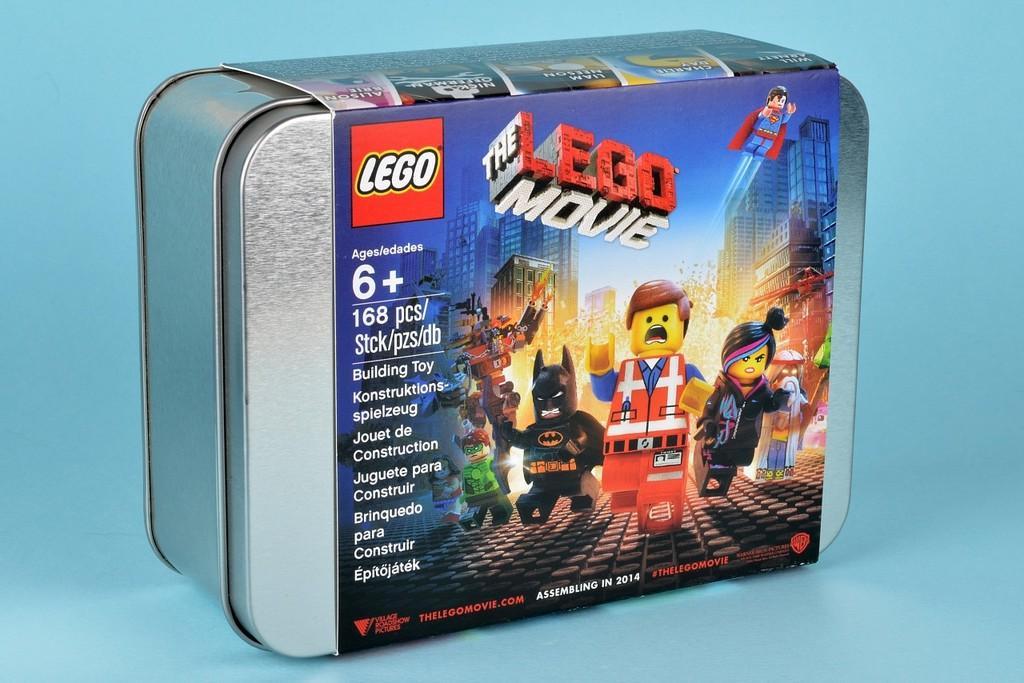Could you give a brief overview of what you see in this image? In this image, we can see a box, on that box there is a sticker, LEGO MOVIE is printed on the sticker. 